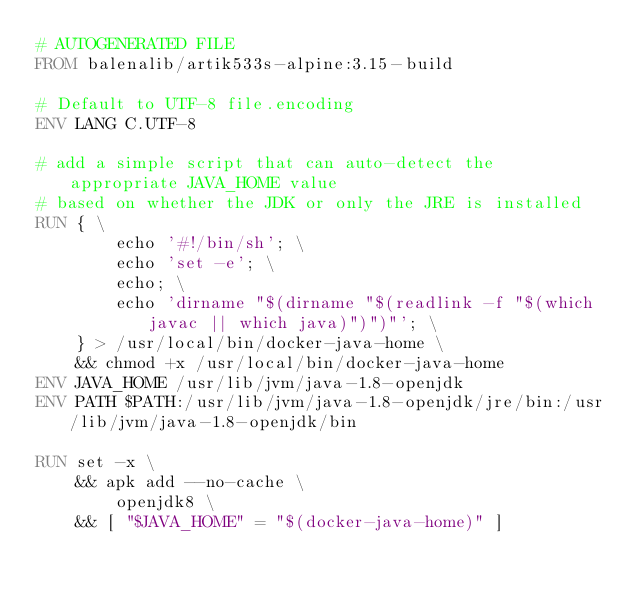<code> <loc_0><loc_0><loc_500><loc_500><_Dockerfile_># AUTOGENERATED FILE
FROM balenalib/artik533s-alpine:3.15-build

# Default to UTF-8 file.encoding
ENV LANG C.UTF-8

# add a simple script that can auto-detect the appropriate JAVA_HOME value
# based on whether the JDK or only the JRE is installed
RUN { \
		echo '#!/bin/sh'; \
		echo 'set -e'; \
		echo; \
		echo 'dirname "$(dirname "$(readlink -f "$(which javac || which java)")")"'; \
	} > /usr/local/bin/docker-java-home \
	&& chmod +x /usr/local/bin/docker-java-home
ENV JAVA_HOME /usr/lib/jvm/java-1.8-openjdk
ENV PATH $PATH:/usr/lib/jvm/java-1.8-openjdk/jre/bin:/usr/lib/jvm/java-1.8-openjdk/bin

RUN set -x \
	&& apk add --no-cache \
		openjdk8 \
	&& [ "$JAVA_HOME" = "$(docker-java-home)" ]
</code> 